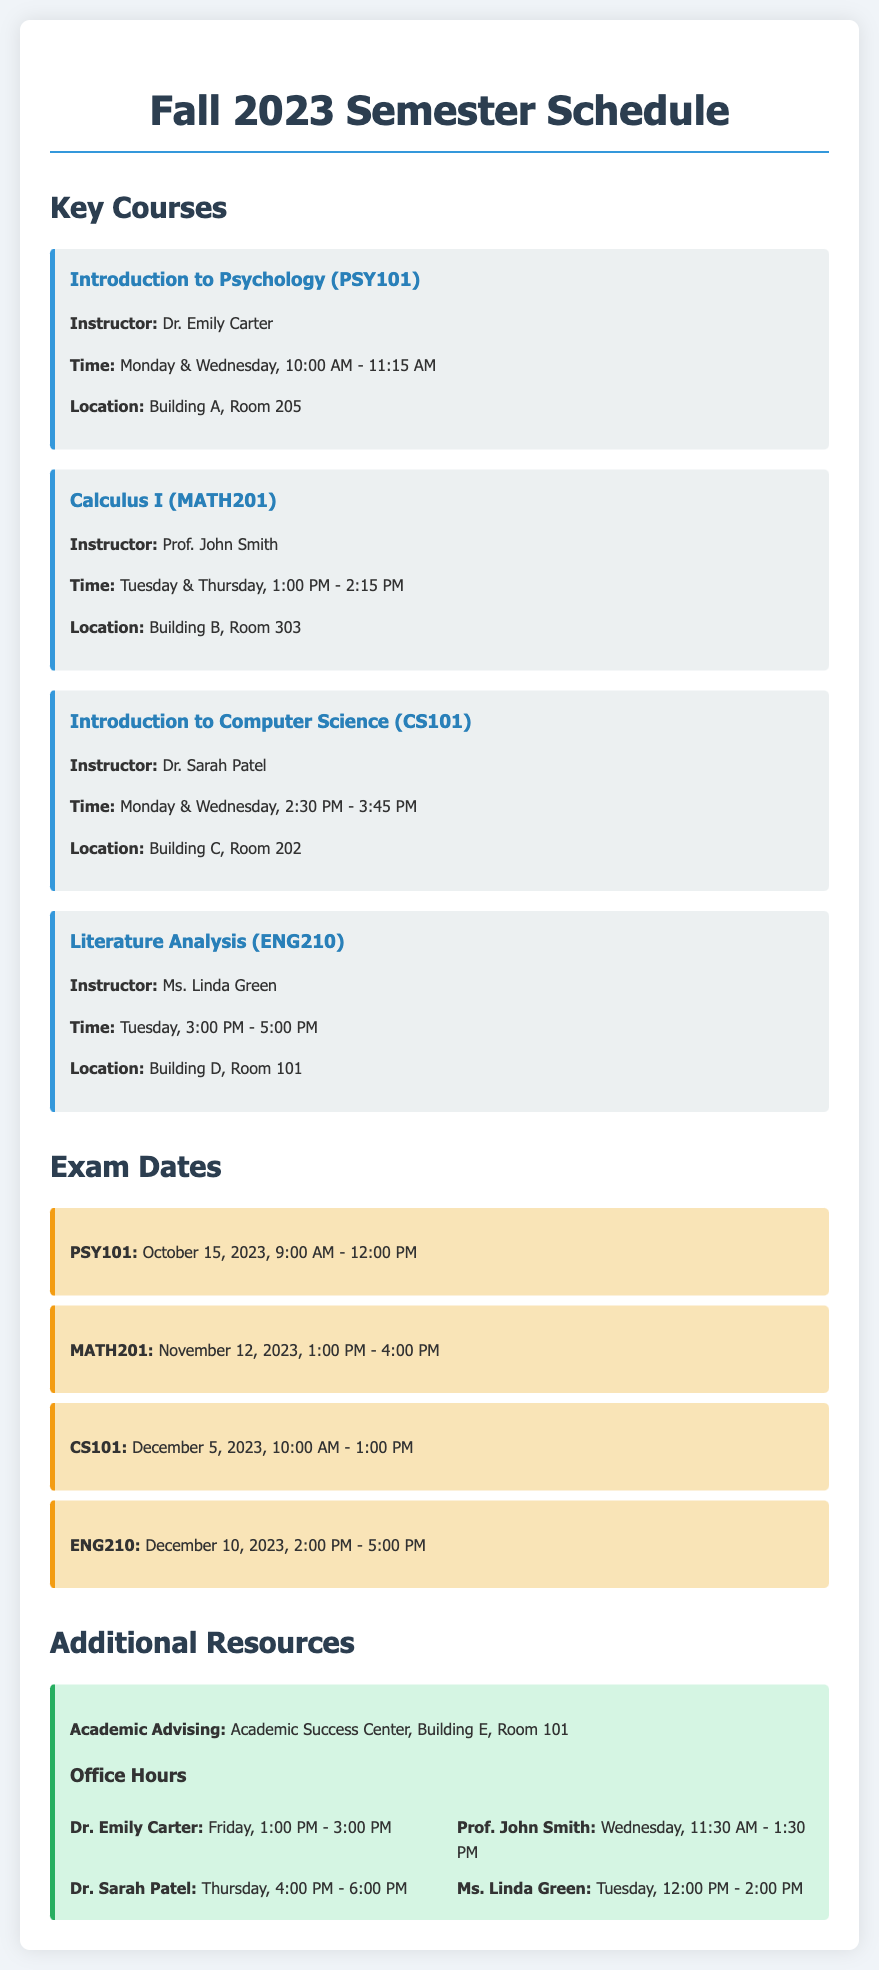What is the class time for Introduction to Psychology? The class time for Introduction to Psychology is listed as Monday & Wednesday, 10:00 AM - 11:15 AM.
Answer: Monday & Wednesday, 10:00 AM - 11:15 AM Who is the instructor for Calculus I? The instructor for Calculus I is Prof. John Smith, as mentioned in the course section.
Answer: Prof. John Smith When is the exam for CS101 scheduled? The exam date for CS101 is indicated in the exam section as December 5, 2023, 10:00 AM - 1:00 PM.
Answer: December 5, 2023, 10:00 AM - 1:00 PM Which building is Literature Analysis held in? Literature Analysis is held in Building D, Room 101, as per the course details.
Answer: Building D, Room 101 How many key courses are listed in the document? The document lists four key courses under the Key Courses section, which can be counted.
Answer: Four What is the time overlap of office hours for Dr. Sarah Patel and Ms. Linda Green? The question requires analyzing their specific office hours; Dr. Sarah Patel is Thursday, 4:00 PM - 6:00 PM, and Ms. Linda Green is Tuesday, 12:00 PM - 2:00 PM, indicating they do not overlap.
Answer: No overlap What type of resource is the Academic Success Center classified as? The Academic Success Center is classified as an additional resource in the document.
Answer: Additional resource What is the room number for Academic Advising? The room number for Academic Advising is referenced as Building E, Room 101.
Answer: Building E, Room 101 